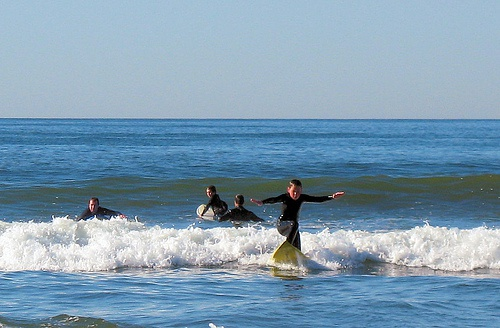Describe the objects in this image and their specific colors. I can see people in lightblue, black, gray, maroon, and blue tones, people in lightblue, black, gray, blue, and maroon tones, surfboard in lightblue, olive, and gray tones, people in lightblue, black, gray, navy, and blue tones, and people in lightblue, black, gray, and maroon tones in this image. 